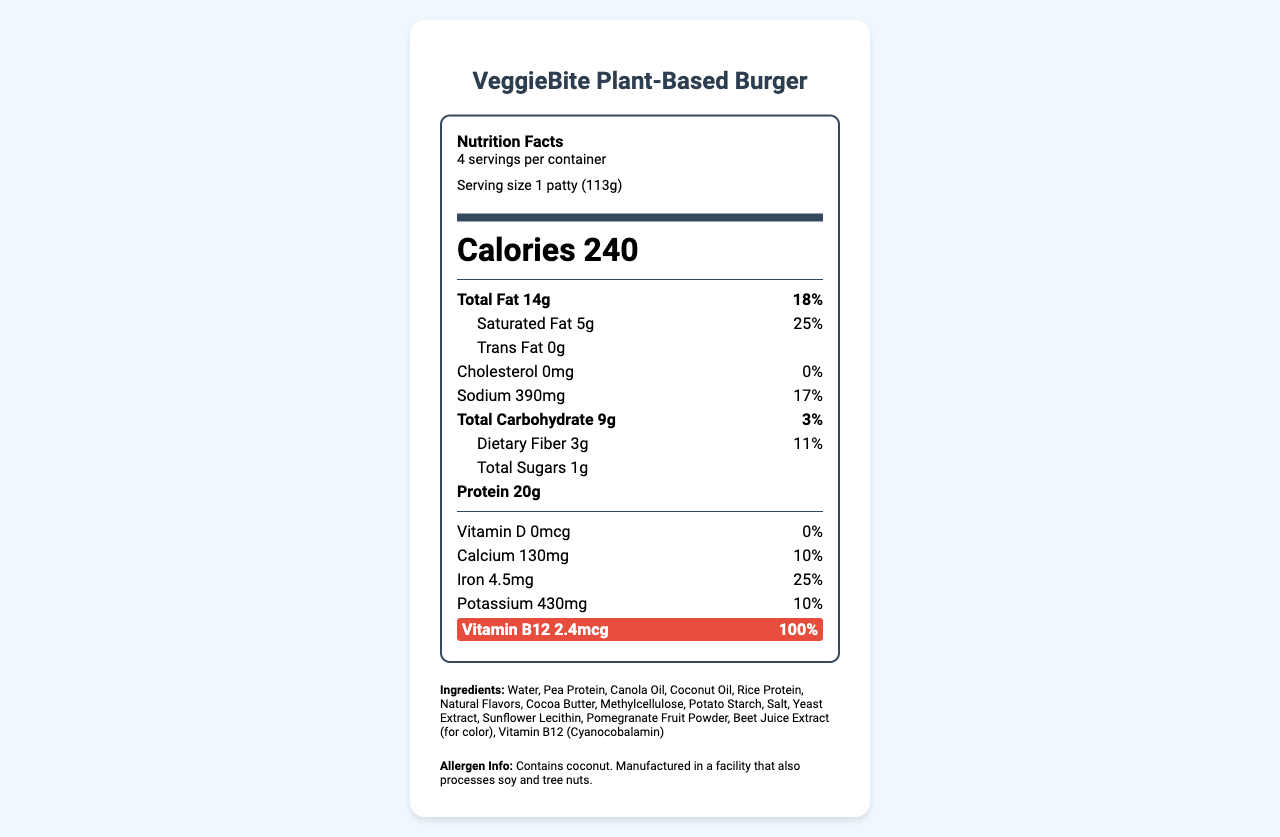what is the serving size of the VeggieBite Plant-Based Burger? The document specifies the serving size as "1 patty (113g)" in the serving section.
Answer: 1 patty (113g) how many calories are there per serving? The document lists the calorie count as "Calories 240" in bold text.
Answer: 240 how much Vitamin B12 does one serving of the product provide? The document shows the Vitamin B12 content as "Vitamin B12 2.4mcg" highlighted in red.
Answer: 2.4 mcg what percentage of the daily value of iron does one serving provide? The document states that one serving provides "Iron 25% DV" under the nutrient list.
Answer: 25% what is the total fat content per serving? The total fat content per serving is listed as "Total Fat 14g" in the document.
Answer: 14g Which of the following allergens are present in the VeggieBite Plant-Based Burger? A. Soy B. Coconut C. Almond The allergen information section states "Contains coconut."
Answer: B what is the sodium content per serving? A. 290mg B. 490mg C. 390mg D. 190mg The document states that the sodium content per serving is "Sodium 390mg."
Answer: C which nutrient is notably highlighted in the document? A. Vitamin D B. Calcium C. Potassium D. Vitamin B12 The Vitamin B12 section is highlighted in the document, emphasizing it as "Vitamin B12 2.4mcg 100% DV".
Answer: D is the VeggieBite Plant-Based Burger certified kosher? The document includes the note "Certified Kosher" under kosher certification.
Answer: Yes describe the main idea of the document. The document displays a labeled nutrition facts diagram, ingredients list, allergen information, ethical and preparation statements, and company details. Highlights include the emphasis on vitamin B12 content.
Answer: The document provides detailed nutritional information about the VeggieBite Plant-Based Burger, highlighting its vitamin B12 content among other nutritional insights, ingredients, allergens, and various claims such as being vegan, non-GMO, and kosher certified. what is the source of the pea protein in the VeggieBite Plant-Based Burger? The document includes the ingredient "Pea Protein" but does not specify the source of it.
Answer: Not enough information 